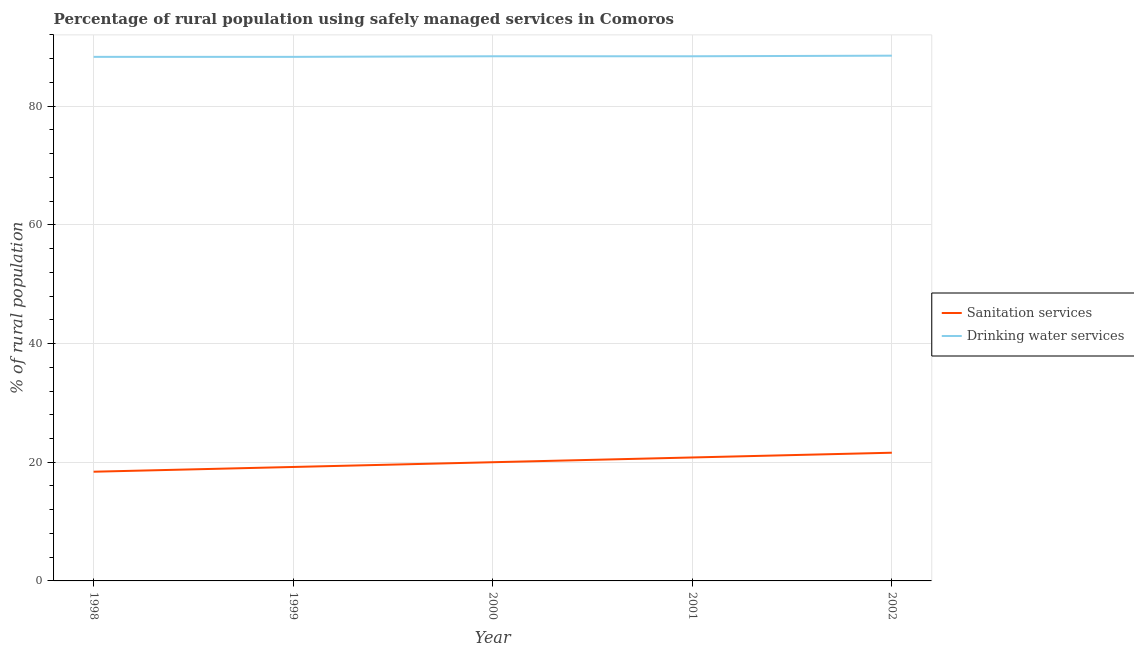How many different coloured lines are there?
Your response must be concise. 2. Does the line corresponding to percentage of rural population who used sanitation services intersect with the line corresponding to percentage of rural population who used drinking water services?
Provide a short and direct response. No. Is the number of lines equal to the number of legend labels?
Offer a terse response. Yes. Across all years, what is the maximum percentage of rural population who used drinking water services?
Keep it short and to the point. 88.5. Across all years, what is the minimum percentage of rural population who used drinking water services?
Provide a succinct answer. 88.3. What is the total percentage of rural population who used drinking water services in the graph?
Keep it short and to the point. 441.9. What is the difference between the percentage of rural population who used drinking water services in 1998 and that in 2000?
Give a very brief answer. -0.1. What is the difference between the percentage of rural population who used drinking water services in 2002 and the percentage of rural population who used sanitation services in 2000?
Give a very brief answer. 68.5. In the year 2000, what is the difference between the percentage of rural population who used sanitation services and percentage of rural population who used drinking water services?
Ensure brevity in your answer.  -68.4. In how many years, is the percentage of rural population who used drinking water services greater than 28 %?
Provide a succinct answer. 5. What is the ratio of the percentage of rural population who used sanitation services in 2001 to that in 2002?
Make the answer very short. 0.96. Is the percentage of rural population who used sanitation services in 2001 less than that in 2002?
Give a very brief answer. Yes. Is the difference between the percentage of rural population who used drinking water services in 1999 and 2002 greater than the difference between the percentage of rural population who used sanitation services in 1999 and 2002?
Offer a terse response. Yes. What is the difference between the highest and the second highest percentage of rural population who used sanitation services?
Your answer should be very brief. 0.8. What is the difference between the highest and the lowest percentage of rural population who used drinking water services?
Provide a succinct answer. 0.2. In how many years, is the percentage of rural population who used drinking water services greater than the average percentage of rural population who used drinking water services taken over all years?
Make the answer very short. 3. Does the percentage of rural population who used sanitation services monotonically increase over the years?
Keep it short and to the point. Yes. How many years are there in the graph?
Your response must be concise. 5. Are the values on the major ticks of Y-axis written in scientific E-notation?
Your answer should be very brief. No. Does the graph contain any zero values?
Keep it short and to the point. No. Does the graph contain grids?
Your answer should be very brief. Yes. Where does the legend appear in the graph?
Make the answer very short. Center right. How many legend labels are there?
Offer a terse response. 2. What is the title of the graph?
Ensure brevity in your answer.  Percentage of rural population using safely managed services in Comoros. Does "Frequency of shipment arrival" appear as one of the legend labels in the graph?
Offer a very short reply. No. What is the label or title of the X-axis?
Provide a short and direct response. Year. What is the label or title of the Y-axis?
Your answer should be compact. % of rural population. What is the % of rural population in Drinking water services in 1998?
Offer a terse response. 88.3. What is the % of rural population in Sanitation services in 1999?
Provide a succinct answer. 19.2. What is the % of rural population of Drinking water services in 1999?
Ensure brevity in your answer.  88.3. What is the % of rural population in Sanitation services in 2000?
Ensure brevity in your answer.  20. What is the % of rural population in Drinking water services in 2000?
Provide a short and direct response. 88.4. What is the % of rural population of Sanitation services in 2001?
Provide a short and direct response. 20.8. What is the % of rural population of Drinking water services in 2001?
Your answer should be compact. 88.4. What is the % of rural population in Sanitation services in 2002?
Provide a short and direct response. 21.6. What is the % of rural population in Drinking water services in 2002?
Keep it short and to the point. 88.5. Across all years, what is the maximum % of rural population in Sanitation services?
Offer a very short reply. 21.6. Across all years, what is the maximum % of rural population of Drinking water services?
Offer a very short reply. 88.5. Across all years, what is the minimum % of rural population of Sanitation services?
Provide a succinct answer. 18.4. Across all years, what is the minimum % of rural population in Drinking water services?
Your response must be concise. 88.3. What is the total % of rural population in Sanitation services in the graph?
Your answer should be compact. 100. What is the total % of rural population in Drinking water services in the graph?
Offer a very short reply. 441.9. What is the difference between the % of rural population of Sanitation services in 1998 and that in 1999?
Keep it short and to the point. -0.8. What is the difference between the % of rural population of Drinking water services in 1998 and that in 1999?
Provide a succinct answer. 0. What is the difference between the % of rural population of Sanitation services in 1998 and that in 2000?
Ensure brevity in your answer.  -1.6. What is the difference between the % of rural population of Drinking water services in 1998 and that in 2000?
Provide a succinct answer. -0.1. What is the difference between the % of rural population in Sanitation services in 1998 and that in 2001?
Provide a succinct answer. -2.4. What is the difference between the % of rural population of Drinking water services in 1998 and that in 2001?
Offer a very short reply. -0.1. What is the difference between the % of rural population in Sanitation services in 1999 and that in 2001?
Provide a short and direct response. -1.6. What is the difference between the % of rural population of Sanitation services in 2000 and that in 2001?
Give a very brief answer. -0.8. What is the difference between the % of rural population of Drinking water services in 2000 and that in 2002?
Your answer should be very brief. -0.1. What is the difference between the % of rural population in Sanitation services in 1998 and the % of rural population in Drinking water services in 1999?
Provide a short and direct response. -69.9. What is the difference between the % of rural population in Sanitation services in 1998 and the % of rural population in Drinking water services in 2000?
Make the answer very short. -70. What is the difference between the % of rural population of Sanitation services in 1998 and the % of rural population of Drinking water services in 2001?
Offer a very short reply. -70. What is the difference between the % of rural population of Sanitation services in 1998 and the % of rural population of Drinking water services in 2002?
Give a very brief answer. -70.1. What is the difference between the % of rural population of Sanitation services in 1999 and the % of rural population of Drinking water services in 2000?
Your answer should be very brief. -69.2. What is the difference between the % of rural population of Sanitation services in 1999 and the % of rural population of Drinking water services in 2001?
Ensure brevity in your answer.  -69.2. What is the difference between the % of rural population of Sanitation services in 1999 and the % of rural population of Drinking water services in 2002?
Your answer should be very brief. -69.3. What is the difference between the % of rural population in Sanitation services in 2000 and the % of rural population in Drinking water services in 2001?
Provide a short and direct response. -68.4. What is the difference between the % of rural population in Sanitation services in 2000 and the % of rural population in Drinking water services in 2002?
Keep it short and to the point. -68.5. What is the difference between the % of rural population of Sanitation services in 2001 and the % of rural population of Drinking water services in 2002?
Offer a very short reply. -67.7. What is the average % of rural population of Drinking water services per year?
Keep it short and to the point. 88.38. In the year 1998, what is the difference between the % of rural population in Sanitation services and % of rural population in Drinking water services?
Your answer should be compact. -69.9. In the year 1999, what is the difference between the % of rural population of Sanitation services and % of rural population of Drinking water services?
Offer a terse response. -69.1. In the year 2000, what is the difference between the % of rural population of Sanitation services and % of rural population of Drinking water services?
Offer a terse response. -68.4. In the year 2001, what is the difference between the % of rural population of Sanitation services and % of rural population of Drinking water services?
Your answer should be very brief. -67.6. In the year 2002, what is the difference between the % of rural population of Sanitation services and % of rural population of Drinking water services?
Provide a short and direct response. -66.9. What is the ratio of the % of rural population of Sanitation services in 1998 to that in 2000?
Offer a very short reply. 0.92. What is the ratio of the % of rural population in Drinking water services in 1998 to that in 2000?
Offer a terse response. 1. What is the ratio of the % of rural population of Sanitation services in 1998 to that in 2001?
Offer a terse response. 0.88. What is the ratio of the % of rural population of Sanitation services in 1998 to that in 2002?
Offer a very short reply. 0.85. What is the ratio of the % of rural population in Sanitation services in 1999 to that in 2000?
Make the answer very short. 0.96. What is the ratio of the % of rural population of Drinking water services in 1999 to that in 2000?
Offer a terse response. 1. What is the ratio of the % of rural population in Sanitation services in 1999 to that in 2001?
Keep it short and to the point. 0.92. What is the ratio of the % of rural population in Sanitation services in 1999 to that in 2002?
Provide a short and direct response. 0.89. What is the ratio of the % of rural population in Sanitation services in 2000 to that in 2001?
Your answer should be very brief. 0.96. What is the ratio of the % of rural population in Drinking water services in 2000 to that in 2001?
Give a very brief answer. 1. What is the ratio of the % of rural population of Sanitation services in 2000 to that in 2002?
Offer a very short reply. 0.93. What is the ratio of the % of rural population of Sanitation services in 2001 to that in 2002?
Your response must be concise. 0.96. What is the ratio of the % of rural population in Drinking water services in 2001 to that in 2002?
Make the answer very short. 1. What is the difference between the highest and the second highest % of rural population of Sanitation services?
Give a very brief answer. 0.8. What is the difference between the highest and the second highest % of rural population of Drinking water services?
Ensure brevity in your answer.  0.1. What is the difference between the highest and the lowest % of rural population of Drinking water services?
Offer a very short reply. 0.2. 